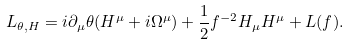Convert formula to latex. <formula><loc_0><loc_0><loc_500><loc_500>L _ { \theta , H } = i \partial _ { \mu } \theta ( H ^ { \mu } + i \Omega ^ { \mu } ) + \frac { 1 } { 2 } f ^ { - 2 } H _ { \mu } H ^ { \mu } + L ( f ) .</formula> 